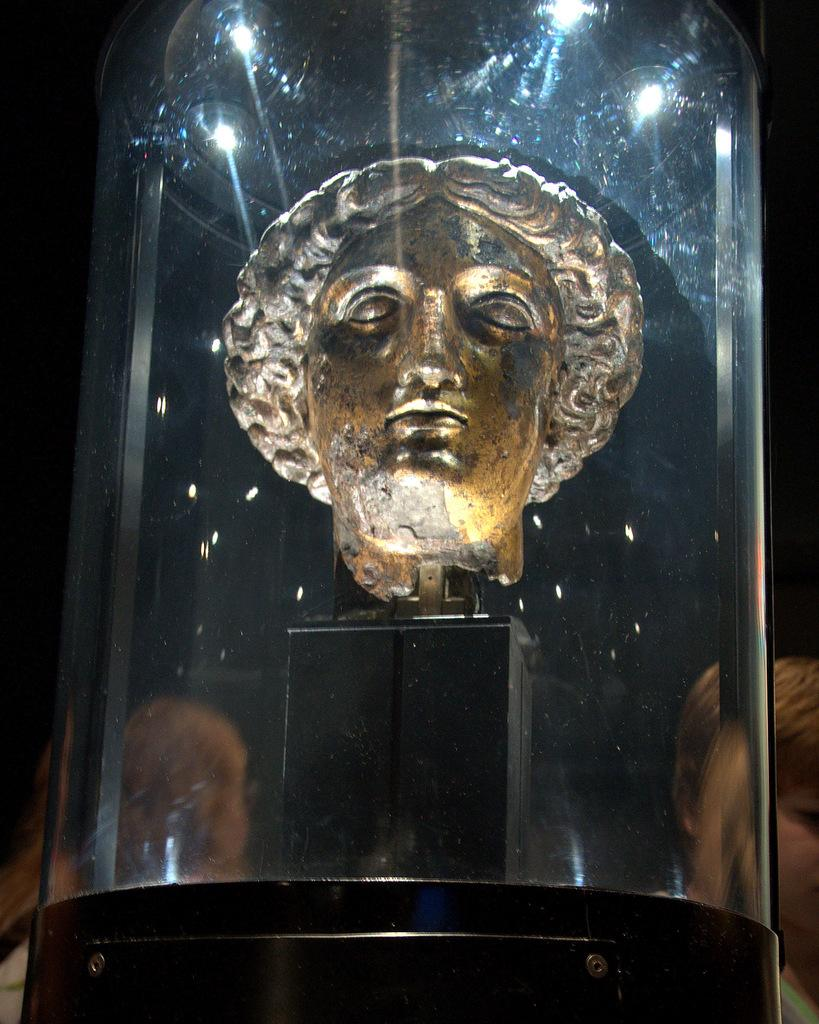What is the main subject in the image? There is a statue in the image. How is the statue contained or displayed? The statue is inside a glass. What can be seen in the background of the image? There are lights visible in the background of the image. What type of liquid can be seen flowing through the throat of the statue in the image? There is no liquid flowing through the throat of the statue in the image, as it is inside a glass. What type of rhythm is the statue dancing to in the image? The statue is not dancing in the image; it is stationary inside the glass. 